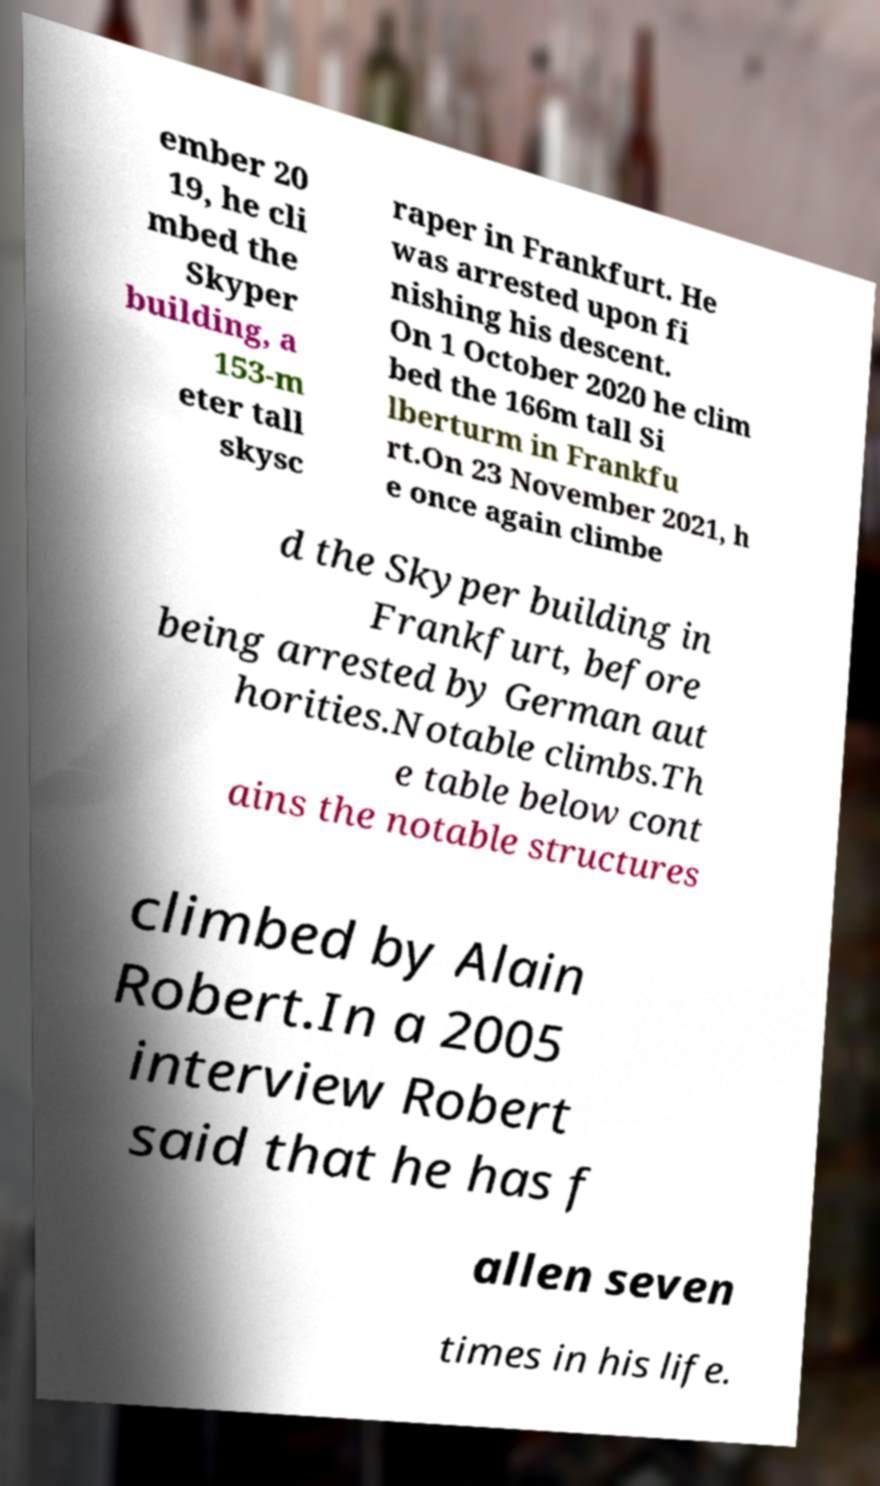Can you accurately transcribe the text from the provided image for me? ember 20 19, he cli mbed the Skyper building, a 153-m eter tall skysc raper in Frankfurt. He was arrested upon fi nishing his descent. On 1 October 2020 he clim bed the 166m tall Si lberturm in Frankfu rt.On 23 November 2021, h e once again climbe d the Skyper building in Frankfurt, before being arrested by German aut horities.Notable climbs.Th e table below cont ains the notable structures climbed by Alain Robert.In a 2005 interview Robert said that he has f allen seven times in his life. 